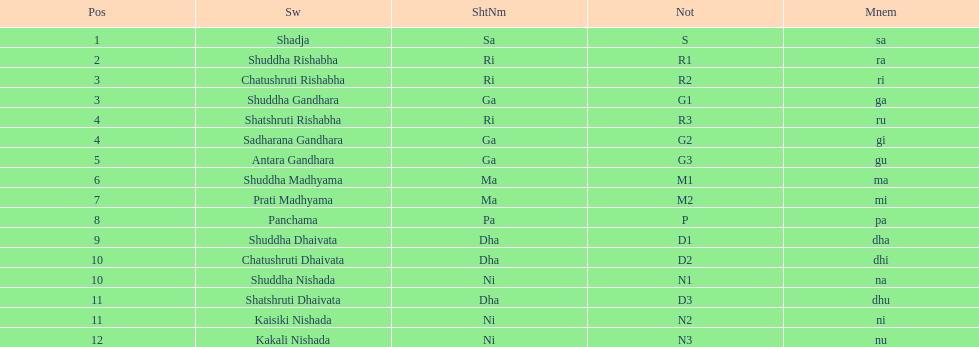What is the overall count of positions mentioned? 16. 